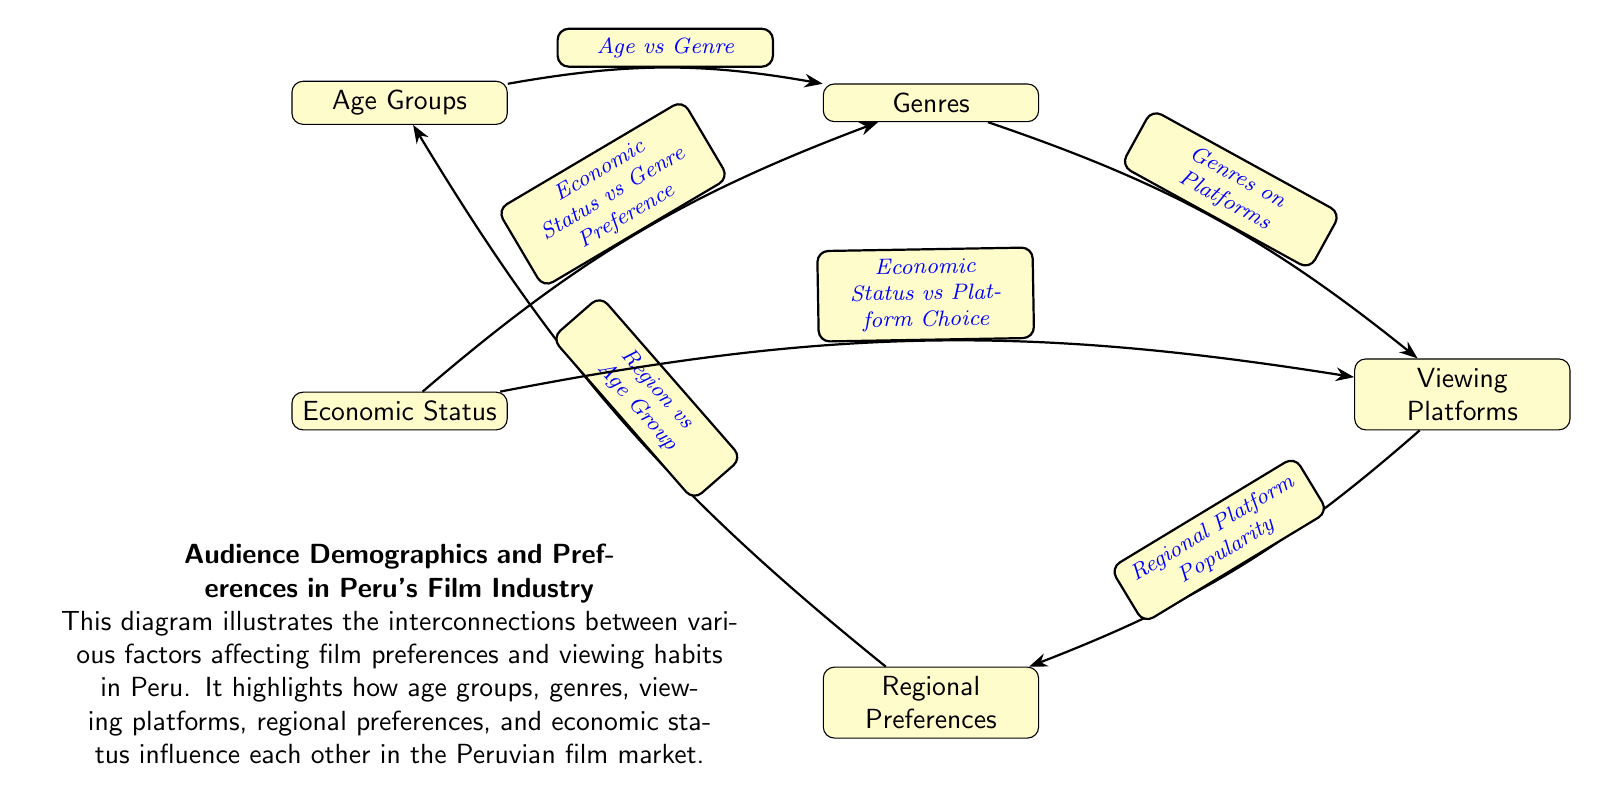What are the main factors influencing preferences in the diagram? The diagram lists five main factors: Age Groups, Genres, Viewing Platforms, Regional Preferences, and Economic Status. These are the nodes that interact with each other to influence audience preferences in Peru's film industry.
Answer: Age Groups, Genres, Viewing Platforms, Regional Preferences, Economic Status How many nodes are present in the diagram? Each of the distinct factors illustrated as nodes in the diagram counts towards the total. There are five nodes listed: Age Groups, Genres, Viewing Platforms, Regional Preferences, and Economic Status.
Answer: 5 What relationship exists between Genre and Economic Status according to the diagram? The diagram shows a directed edge labeled "Economic Status vs Genre Preference" that indicates a relationship where Economic Status influences Genre preferences, suggesting that people's economic conditions affect the film genres they prefer.
Answer: Economic Status vs Genre Preference What connects Viewing Platforms to Regional Preferences? The diagram indicates a direct relationship with the edge labeled "Regional Platform Popularity" which suggests that viewing platforms are influenced by regional preferences, illustrating how different regions may favor certain platforms for watching films.
Answer: Regional Platform Popularity Which two nodes are connected by an edge labeled "Age vs Genre"? The nodes connected by this edge are Age Groups and Genres, indicating a specific relationship where the age group of the audience affects the types of genres they prefer.
Answer: Age Groups and Genres Which demographic factor directly influences both Genres and Viewing Platforms? Economic Status is the factor that directly influences both Genres and Viewing Platforms as indicated by the edges labeled "Economic Status vs Genre Preference" and "Economic Status vs Platform Choice." This shows its broader impact on both aspects.
Answer: Economic Status What is the nature of the interaction among the nodes in the diagram? The interactions are bidirectional, meaning that relations like "Region vs Age Group" and "Age vs Genre" indicate that changes in one factor can influence the other, demonstrating a complex interconnectivity among the different demographic factors.
Answer: Bidirectional interactions How does the diagram categorize the connections between Regional Preferences and Age Groups? The edge labeled "Region vs Age Group" shows a relationship where regional preferences do influence the age groups, suggesting that different regions may resonate more with certain age demographics.
Answer: Region vs Age Group What is the significance of the edge "Genres on Platforms" in the context of the audience's viewing habits? The edge labeled "Genres on Platforms" illustrates a relationship that suggests the connection between the types of genres preferred by audiences and the platforms they choose to view those genres, highlighting consumer behavior in film consumption.
Answer: Genres on Platforms 